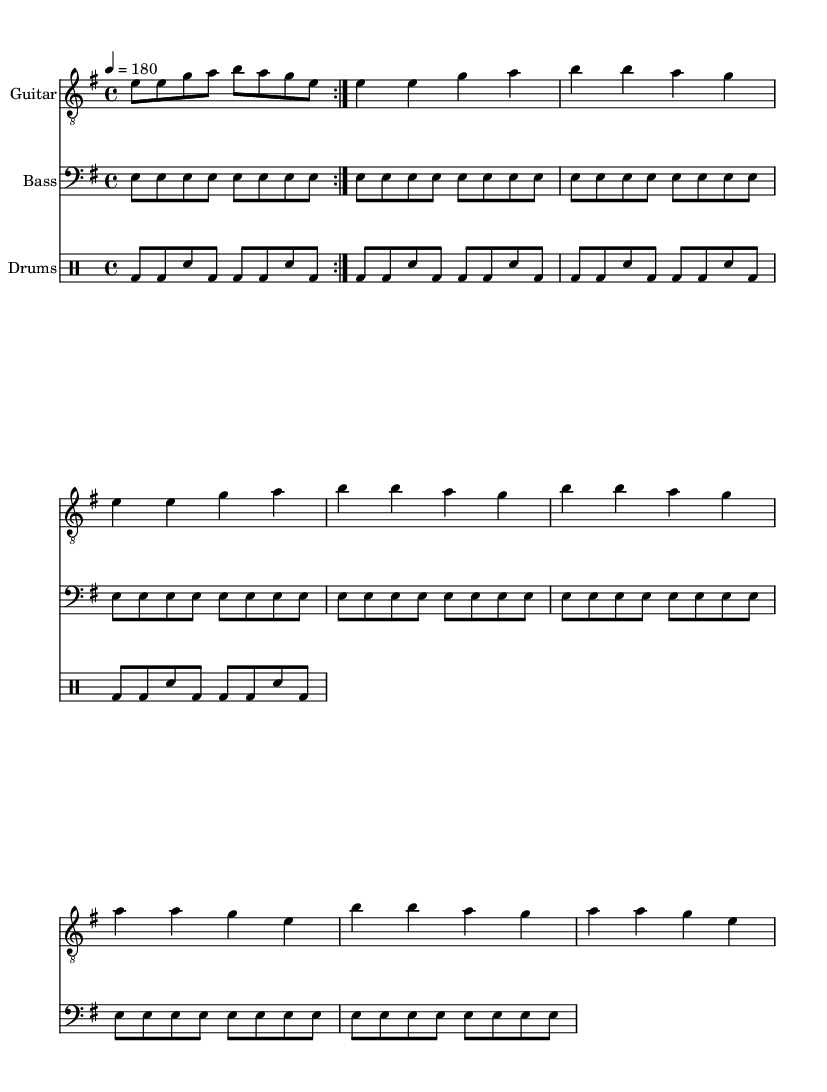What is the key signature of this music? The key signature indicates that the music is in E minor, which has one sharp (F#). You can determine this from the key signature notation at the beginning of the first staff.
Answer: E minor What is the time signature of this music? The time signature displayed at the beginning of the music is 4/4, meaning there are four beats in each measure, and the quarter note gets one beat. This is visible right after the key signature.
Answer: 4/4 What is the tempo marking for this music? The tempo marking is indicated as "4 = 180," which means there are 180 beats per minute, showing it is a fast-paced track. This information is found in the tempo instruction at the beginning.
Answer: 180 How many times is the guitar riff repeated in the intro? The guitar riff is indicated to be repeated two times in the intro, as shown by the "repeat volta 2" marking at the beginning of the guitar section.
Answer: 2 Which instrument plays the bass part? The bass part is explicitly labeled in the sheet music with the staff's instrument name "Bass," indicating which instrument plays the bass notes.
Answer: Bass What is the structure of the chorus in this piece? The chorus section appears to repeat the same rhythmic and melodic pattern as the verse but features different notes. Thus, while it shares some structural similarity, the specific notes and repetition highlight the chorus' role in providing musical variety. This can be observed within the guitar part where the chorus is described as a different section following the verse pattern.
Answer: Different notes What genre does this music represent? The music's fast tempo, simple chord structure, and aggressive style, focusing on themes of overcoming challenges, indicate that this piece represents the punk genre, which is characterized by these musical traits. This specific focus on overcoming physical challenges in sports solidifies its punk identity.
Answer: Punk 